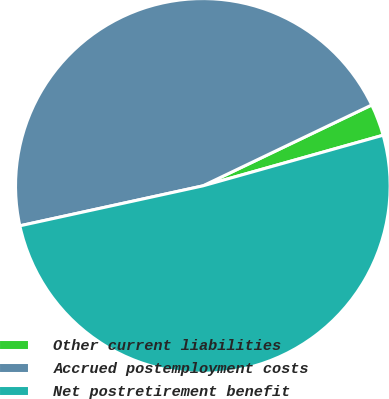Convert chart. <chart><loc_0><loc_0><loc_500><loc_500><pie_chart><fcel>Other current liabilities<fcel>Accrued postemployment costs<fcel>Net postretirement benefit<nl><fcel>2.75%<fcel>46.31%<fcel>50.94%<nl></chart> 